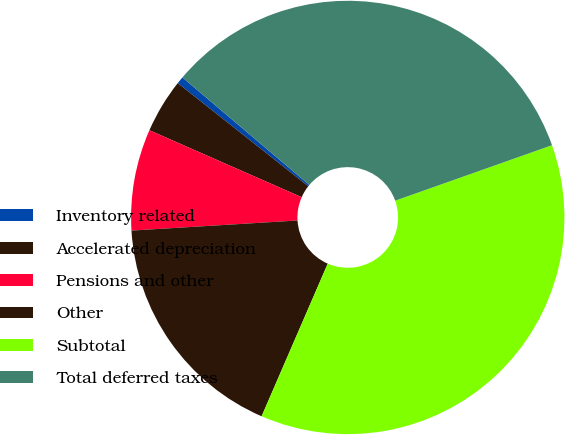Convert chart. <chart><loc_0><loc_0><loc_500><loc_500><pie_chart><fcel>Inventory related<fcel>Accelerated depreciation<fcel>Pensions and other<fcel>Other<fcel>Subtotal<fcel>Total deferred taxes<nl><fcel>0.54%<fcel>4.05%<fcel>7.56%<fcel>17.53%<fcel>36.92%<fcel>33.41%<nl></chart> 